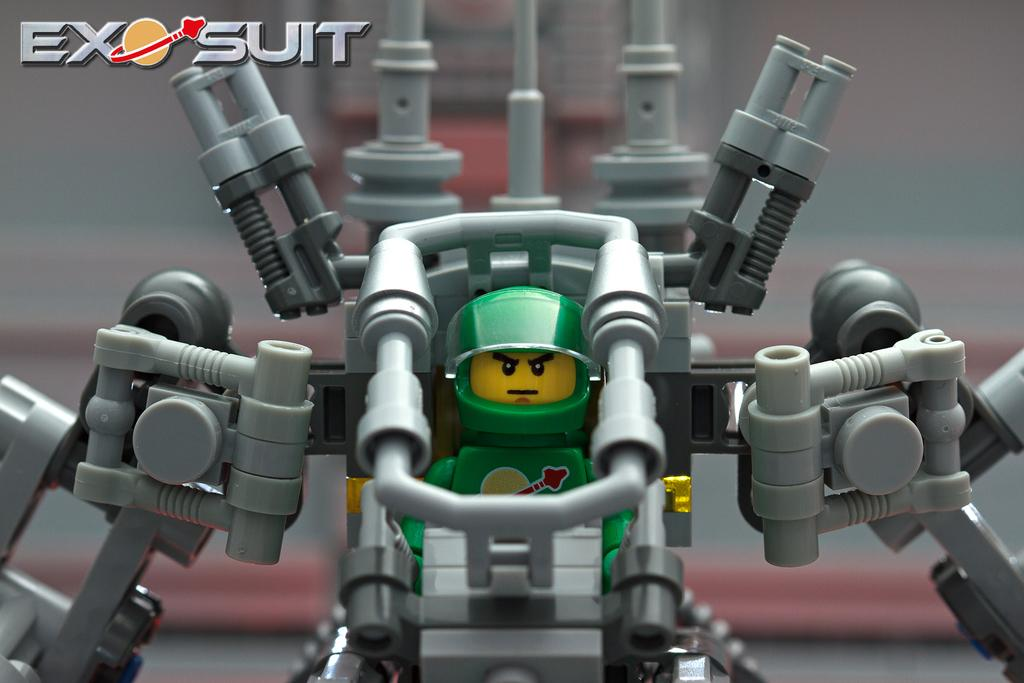What type of toy is in the image? There is a robot toy in the image. Can you describe the background of the image? The background of the image is blurred. Is there any additional information or markings on the image? Yes, there is a watermark at the top left side of the image. Where is the crown placed on the robot toy in the image? There is no crown present on the robot toy in the image. What type of bread is visible in the image? There is no bread or loaf present in the image. 